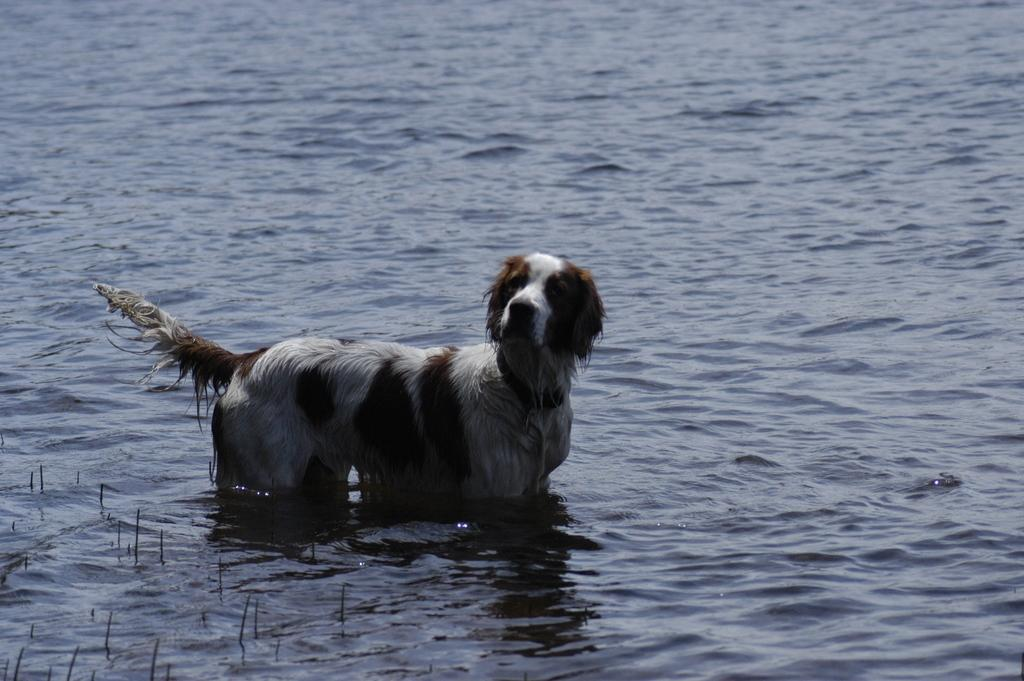What type of animal is in the image? There is a dog in the image. Can you describe the color of the dog? The dog is brown and white in color. What can be seen in the background of the image? There is water visible in the background of the image. What type of key is the dog holding in the image? There is no key present in the image; it features a dog in a brown and white color. Can you describe the fireman attending to the dog in the image? There is no fireman present in the image; it only features a dog and water in the background. 